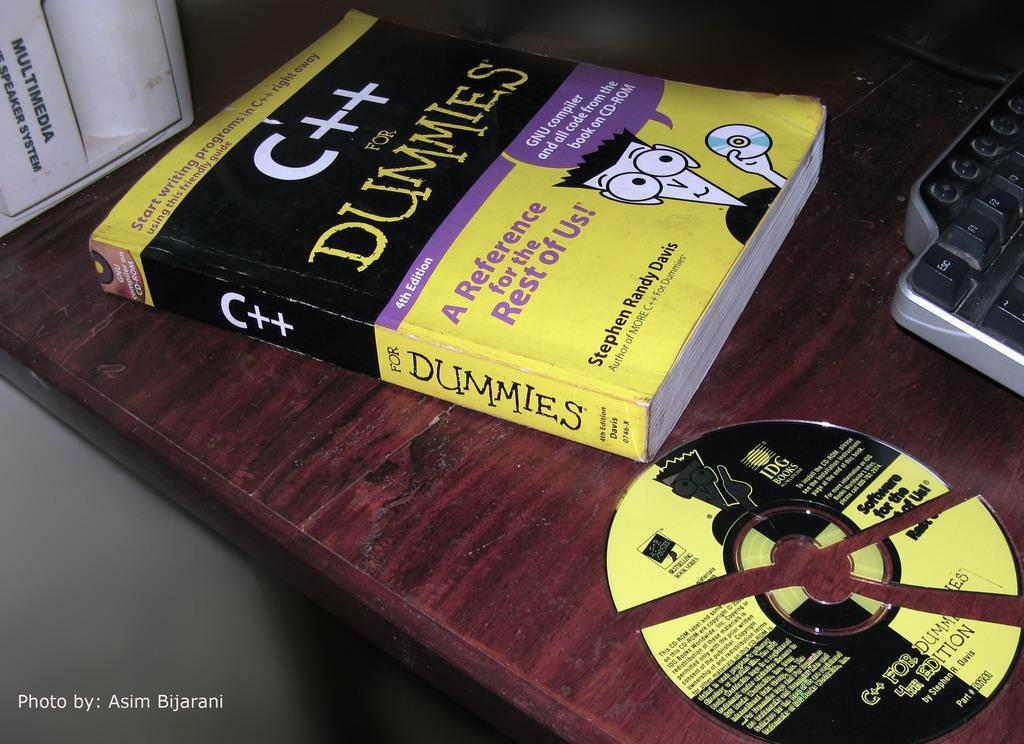<image>
Provide a brief description of the given image. A desk with a book about a subject for dummies with a broken cd disc next to it 